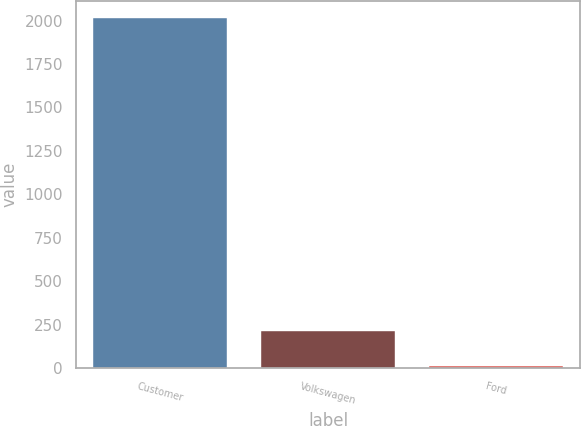Convert chart. <chart><loc_0><loc_0><loc_500><loc_500><bar_chart><fcel>Customer<fcel>Volkswagen<fcel>Ford<nl><fcel>2014<fcel>213.1<fcel>13<nl></chart> 